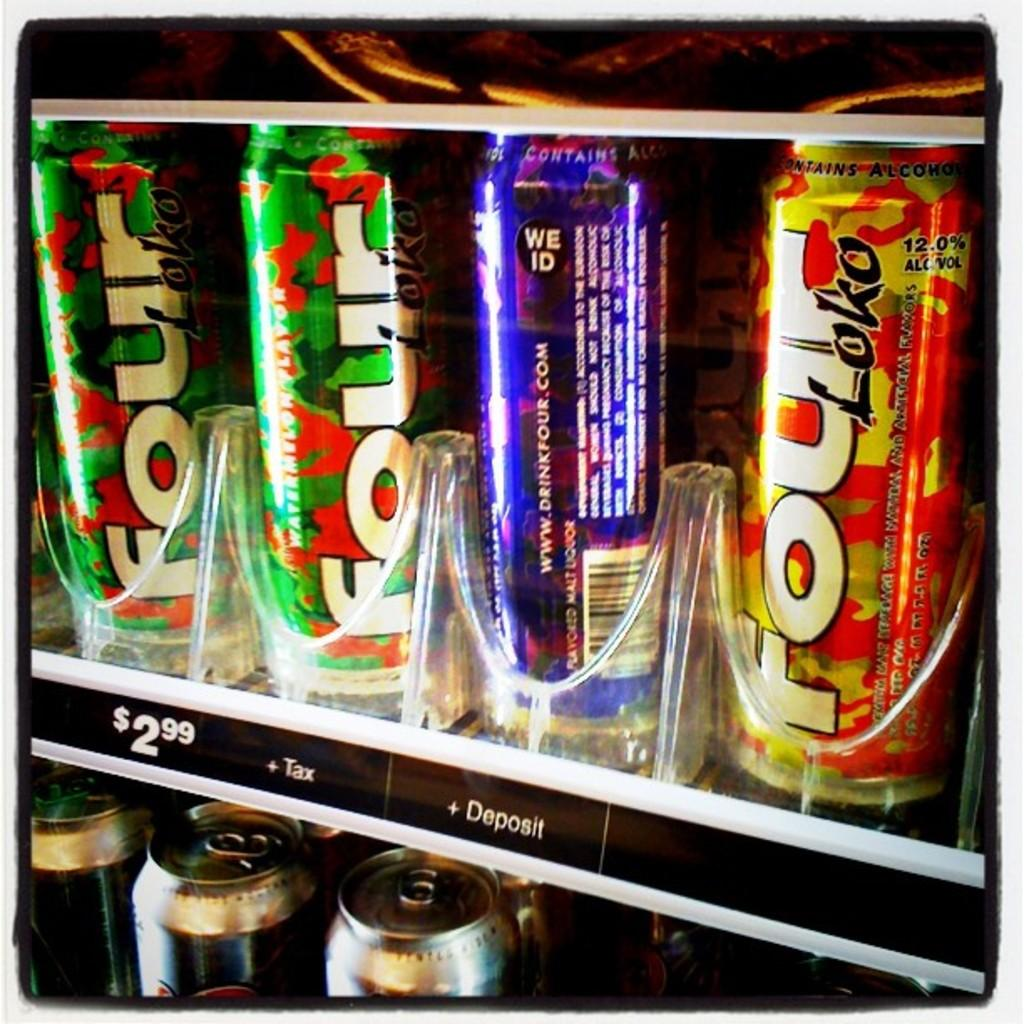<image>
Share a concise interpretation of the image provided. A vending machine with cans of Four Loko in it. 